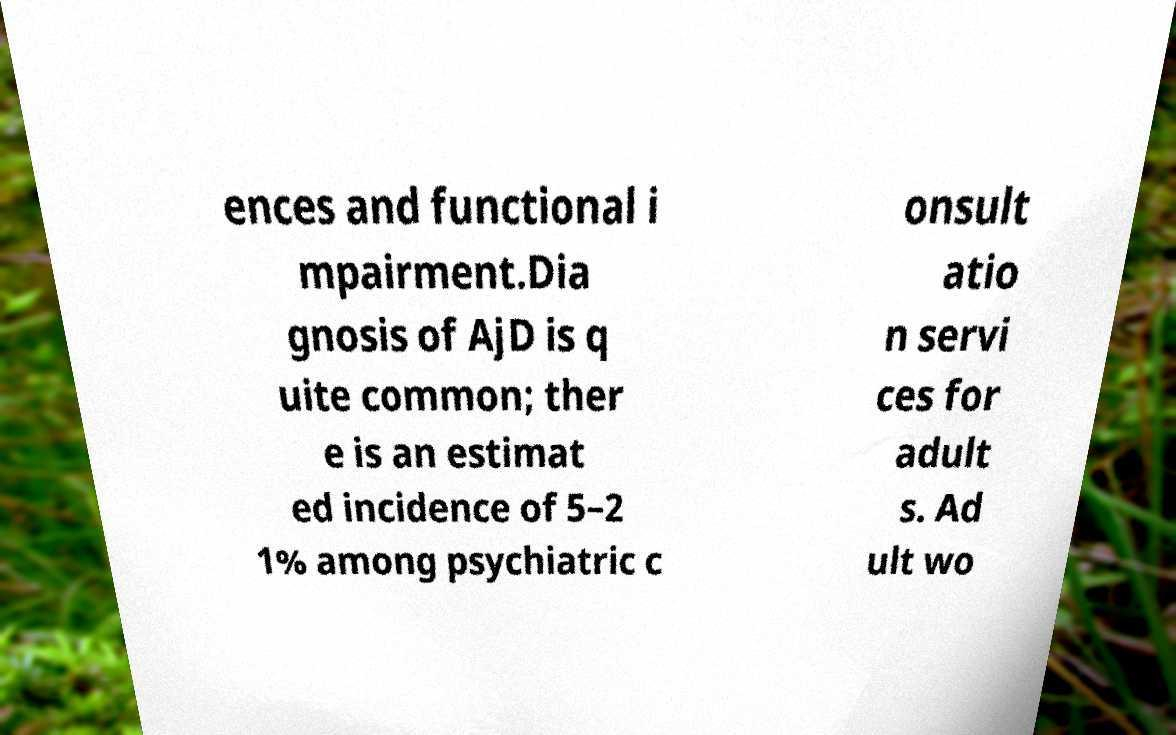Could you extract and type out the text from this image? ences and functional i mpairment.Dia gnosis of AjD is q uite common; ther e is an estimat ed incidence of 5–2 1% among psychiatric c onsult atio n servi ces for adult s. Ad ult wo 